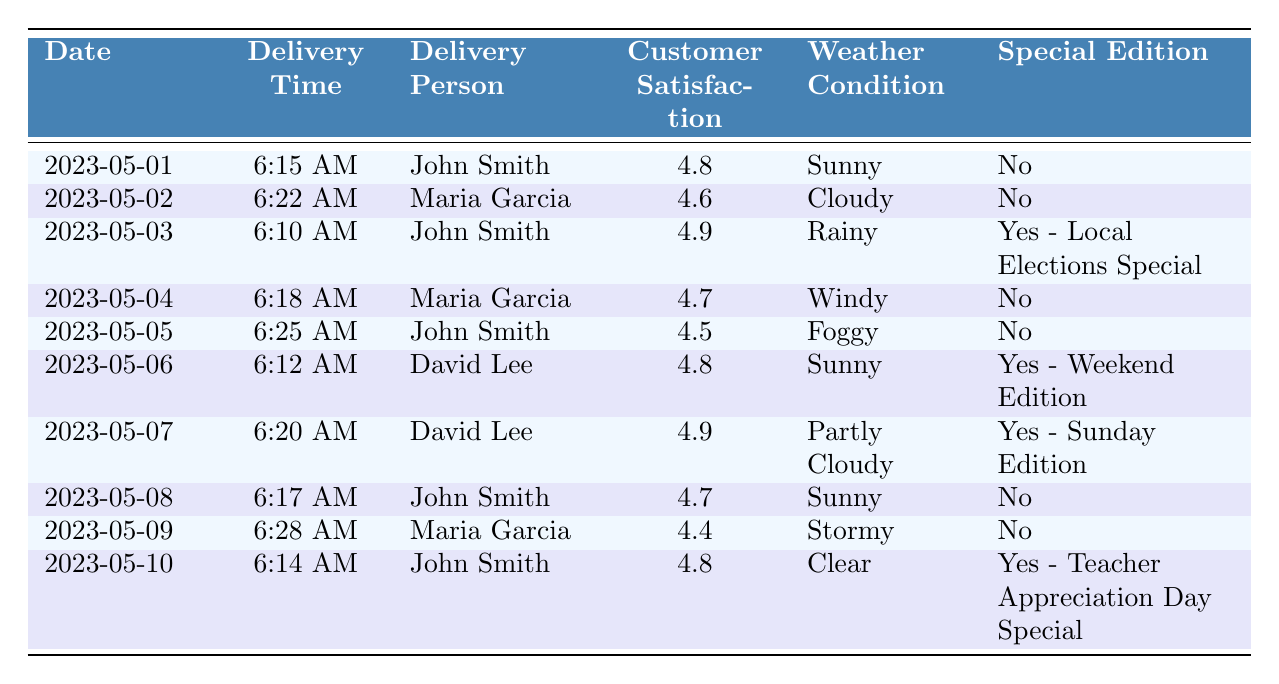What was the delivery time on May 01, 2023? Looking at the row for May 01, 2023, the delivery time is listed as 6:15 AM.
Answer: 6:15 AM Who was the delivery person on May 06, 2023? Referring to the entry for May 06, 2023, it shows that the delivery person was David Lee.
Answer: David Lee What was the customer satisfaction rating on May 09, 2023? The rating for customer satisfaction on May 09, 2023, is stated as 4.4.
Answer: 4.4 Was there a special edition delivered on May 03, 2023? Checking the entry for May 03, 2023, it indicates that there was a special edition for the Local Elections.
Answer: Yes What is the average customer satisfaction rating for John Smith? John Smith has ratings of 4.8, 4.9, 4.5, and 4.7 over four entries. The sum is 4.8 + 4.9 + 4.5 + 4.7 = 19.9. Dividing by 4 gives an average of 19.9 / 4 = 4.975.
Answer: 4.975 Which delivery person had the highest customer satisfaction rating? Each person's ratings are tallied: John Smith has 4.8, 4.9, 4.5, 4.7 (average = 4.975), Maria Garcia has 4.6, 4.7, 4.4 (average = 4.533), and David Lee has 4.8, 4.9 (average = 4.85). John Smith has the highest average rating at 4.975.
Answer: John Smith On which date did David Lee deliver a special edition? David Lee delivered a special edition on May 06, 2023, as indicated in the row for that date.
Answer: May 06, 2023 How many days had a customer satisfaction rating below 4.5? Looking through the table, only May 09 had a rating below 4.5 (4.4). Therefore, there is 1 day.
Answer: 1 day What was the weather condition on May 10, 2023? For May 10, 2023, the weather condition is noted as Clear.
Answer: Clear How many deliveries occurred in rainy weather? Checking the table, there is only one entry for rainy weather, which is on May 03, 2023.
Answer: 1 delivery 